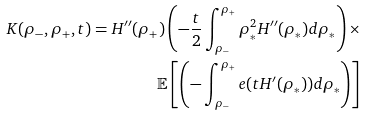Convert formula to latex. <formula><loc_0><loc_0><loc_500><loc_500>K ( \rho _ { - } , \rho _ { + } , t ) = H ^ { \prime \prime } ( \rho _ { + } ) \left ( - \frac { t } { 2 } \int _ { \rho _ { - } } ^ { \rho _ { + } } \rho _ { * } ^ { 2 } H ^ { \prime \prime } ( \rho _ { * } ) d \rho _ { * } \right ) \times \\ \mathbb { E } \left [ \left ( - \int _ { \rho _ { - } } ^ { \rho _ { + } } e ( t H ^ { \prime } ( \rho _ { * } ) ) d \rho _ { * } \right ) \right ]</formula> 